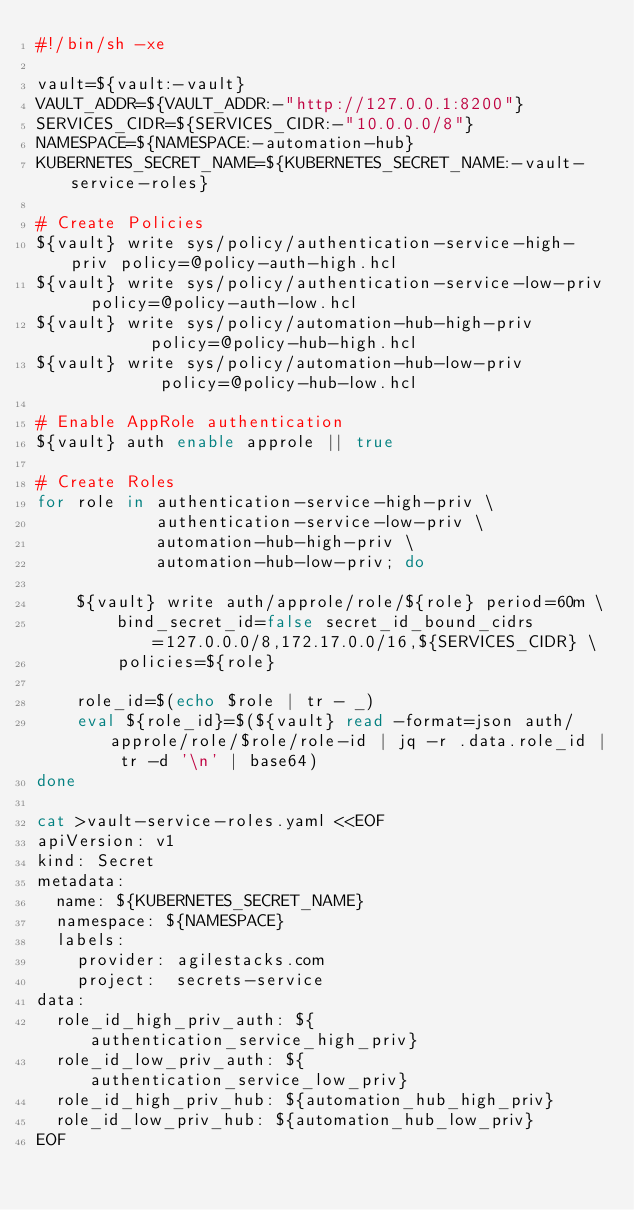<code> <loc_0><loc_0><loc_500><loc_500><_Bash_>#!/bin/sh -xe

vault=${vault:-vault}
VAULT_ADDR=${VAULT_ADDR:-"http://127.0.0.1:8200"}
SERVICES_CIDR=${SERVICES_CIDR:-"10.0.0.0/8"}
NAMESPACE=${NAMESPACE:-automation-hub}
KUBERNETES_SECRET_NAME=${KUBERNETES_SECRET_NAME:-vault-service-roles}

# Create Policies
${vault} write sys/policy/authentication-service-high-priv policy=@policy-auth-high.hcl
${vault} write sys/policy/authentication-service-low-priv  policy=@policy-auth-low.hcl
${vault} write sys/policy/automation-hub-high-priv         policy=@policy-hub-high.hcl
${vault} write sys/policy/automation-hub-low-priv          policy=@policy-hub-low.hcl

# Enable AppRole authentication
${vault} auth enable approle || true

# Create Roles
for role in authentication-service-high-priv \
            authentication-service-low-priv \
            automation-hub-high-priv \
            automation-hub-low-priv; do

    ${vault} write auth/approle/role/${role} period=60m \
        bind_secret_id=false secret_id_bound_cidrs=127.0.0.0/8,172.17.0.0/16,${SERVICES_CIDR} \
        policies=${role}

    role_id=$(echo $role | tr - _)
    eval ${role_id}=$(${vault} read -format=json auth/approle/role/$role/role-id | jq -r .data.role_id | tr -d '\n' | base64)
done

cat >vault-service-roles.yaml <<EOF
apiVersion: v1
kind: Secret
metadata:
  name: ${KUBERNETES_SECRET_NAME}
  namespace: ${NAMESPACE}
  labels:
    provider: agilestacks.com
    project:  secrets-service
data:
  role_id_high_priv_auth: ${authentication_service_high_priv}
  role_id_low_priv_auth: ${authentication_service_low_priv}
  role_id_high_priv_hub: ${automation_hub_high_priv}
  role_id_low_priv_hub: ${automation_hub_low_priv}
EOF
</code> 